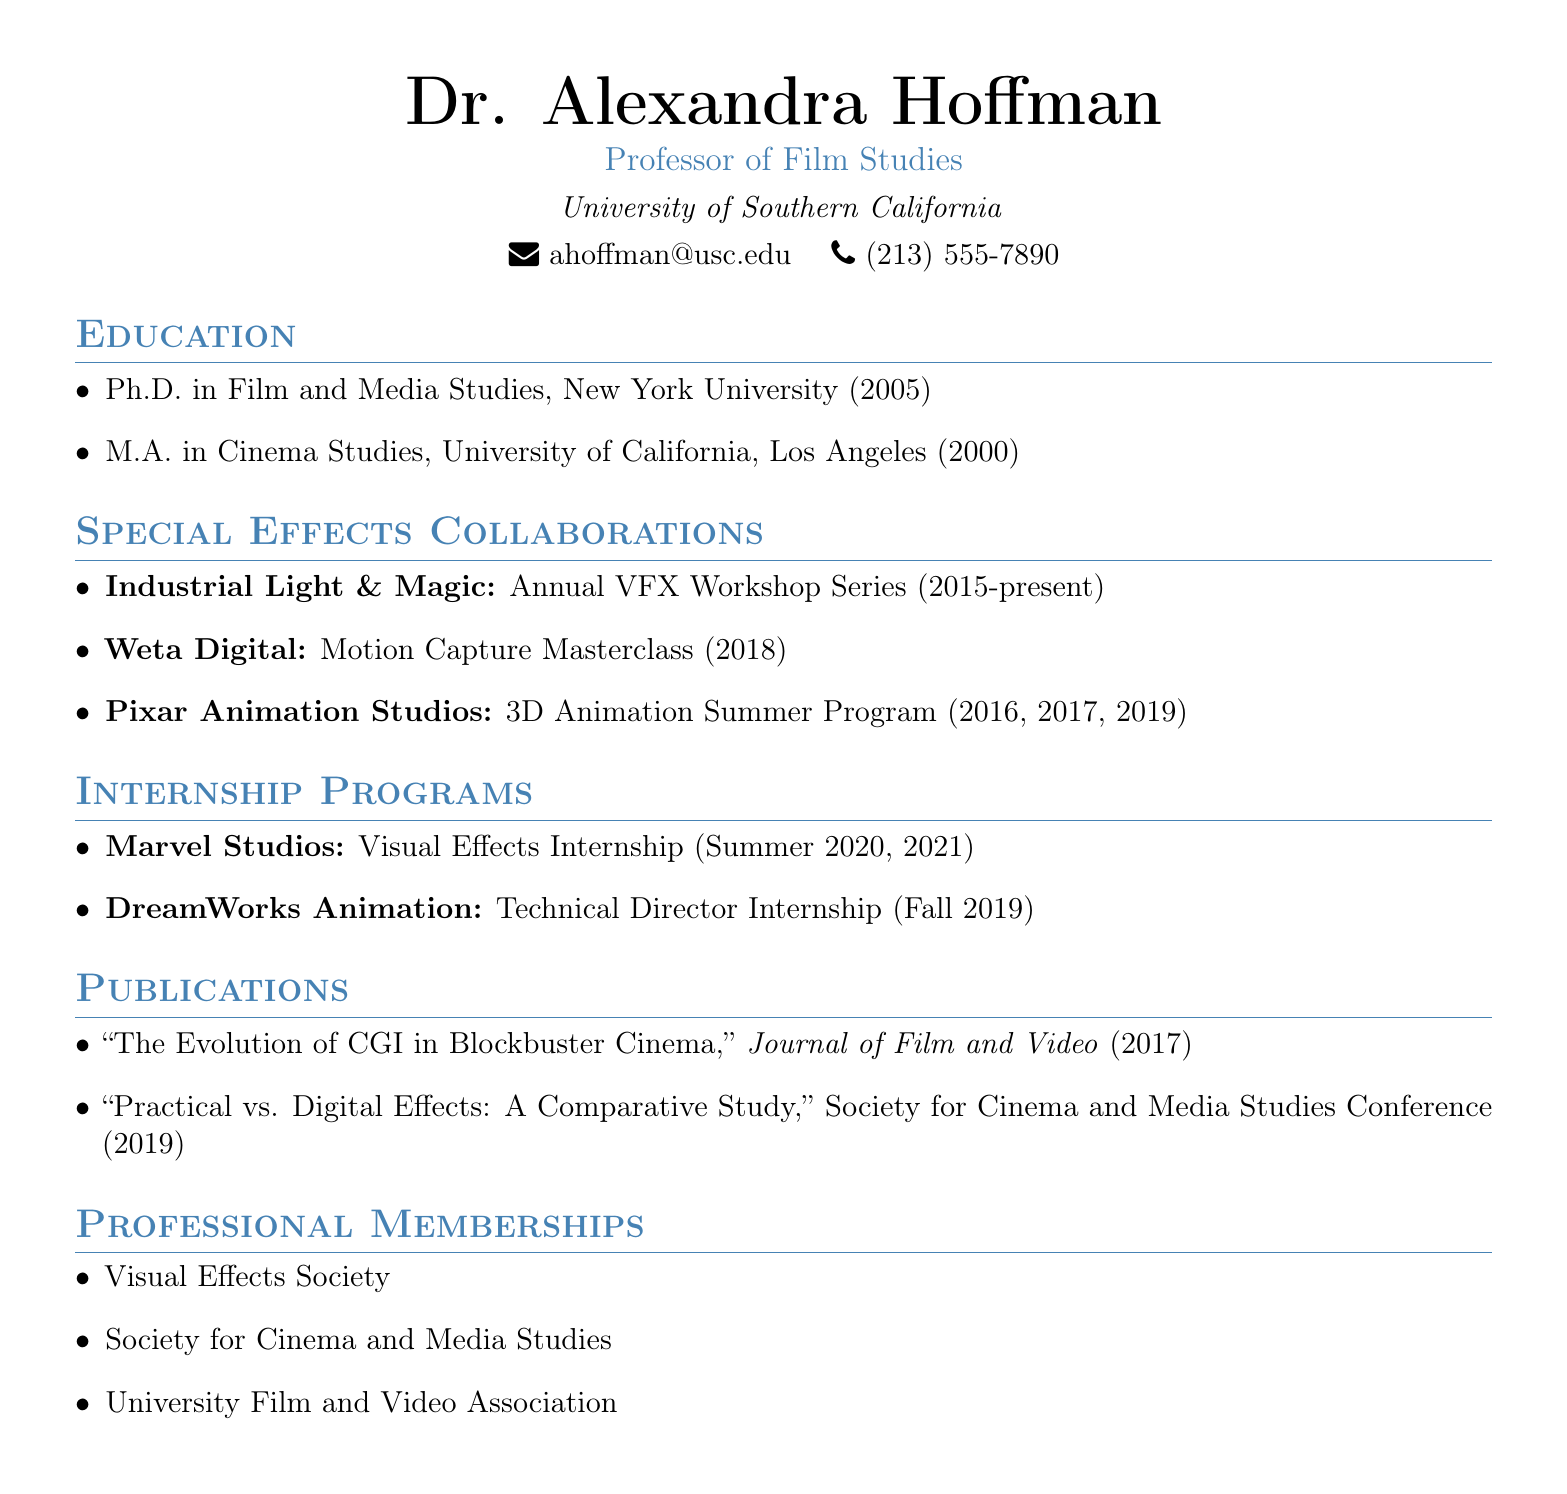What is the name of the professor? The name of the professor is stated at the beginning of the document.
Answer: Dr. Alexandra Hoffman What is the title of the visual effects workshop series with Industrial Light & Magic? The document lists the specific collaboration with the studio along with its title.
Answer: Annual VFX Workshop Series In what year did the Motion Capture Masterclass with Weta Digital occur? The date of this specific project is mentioned in the section on special effects collaborations.
Answer: 2018 How many years did Dr. Hoffman participate in the 3D Animation Summer Program with Pixar Animation Studios? The document mentions the specific years of participation in the program.
Answer: 3 years What is the name of the internship program with Marvel Studios? The document specifies the internship program offered by Marvel Studios.
Answer: Visual Effects Internship Which professional membership is related to visual effects? The document lists professional memberships, including one specific to visual effects.
Answer: Visual Effects Society What does Dr. Hoffman’s Ph.D. focus on? The degree context in the document specifies the field of study for her Ph.D.
Answer: Film and Media Studies Which journal published Dr. Hoffman’s article on CGI? The document provides the title and the journal of the publication.
Answer: Journal of Film and Video 